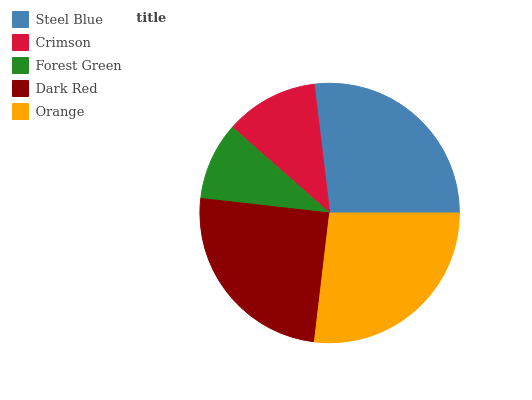Is Forest Green the minimum?
Answer yes or no. Yes. Is Steel Blue the maximum?
Answer yes or no. Yes. Is Crimson the minimum?
Answer yes or no. No. Is Crimson the maximum?
Answer yes or no. No. Is Steel Blue greater than Crimson?
Answer yes or no. Yes. Is Crimson less than Steel Blue?
Answer yes or no. Yes. Is Crimson greater than Steel Blue?
Answer yes or no. No. Is Steel Blue less than Crimson?
Answer yes or no. No. Is Dark Red the high median?
Answer yes or no. Yes. Is Dark Red the low median?
Answer yes or no. Yes. Is Forest Green the high median?
Answer yes or no. No. Is Crimson the low median?
Answer yes or no. No. 